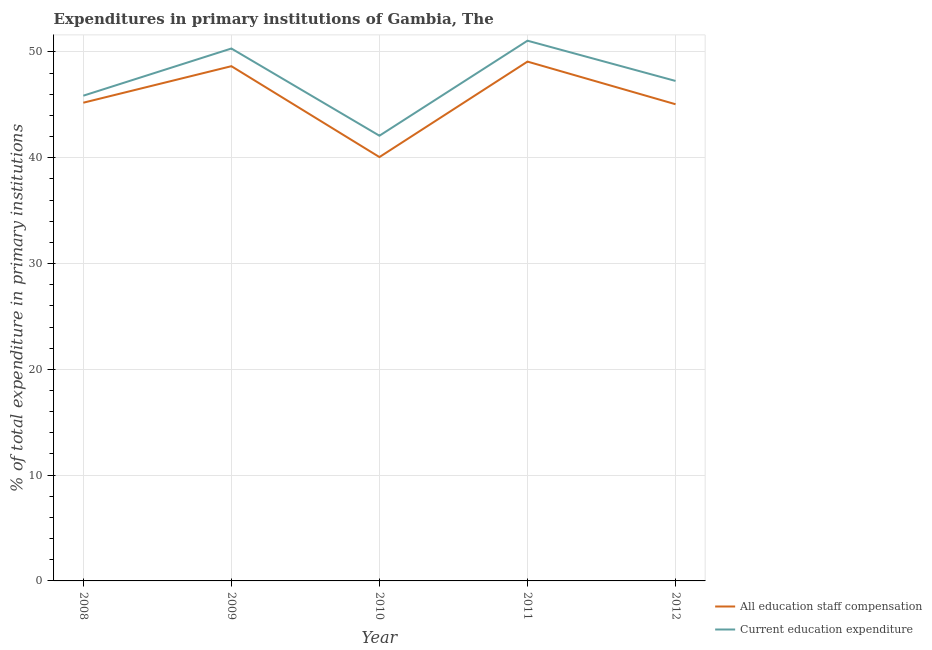Does the line corresponding to expenditure in staff compensation intersect with the line corresponding to expenditure in education?
Keep it short and to the point. No. What is the expenditure in education in 2012?
Offer a very short reply. 47.26. Across all years, what is the maximum expenditure in education?
Make the answer very short. 51.07. Across all years, what is the minimum expenditure in staff compensation?
Provide a short and direct response. 40.06. In which year was the expenditure in education maximum?
Your answer should be very brief. 2011. What is the total expenditure in staff compensation in the graph?
Your response must be concise. 228.07. What is the difference between the expenditure in staff compensation in 2008 and that in 2009?
Give a very brief answer. -3.45. What is the difference between the expenditure in education in 2010 and the expenditure in staff compensation in 2008?
Give a very brief answer. -3.12. What is the average expenditure in staff compensation per year?
Keep it short and to the point. 45.61. In the year 2010, what is the difference between the expenditure in staff compensation and expenditure in education?
Your response must be concise. -2.02. In how many years, is the expenditure in staff compensation greater than 46 %?
Your answer should be compact. 2. What is the ratio of the expenditure in education in 2008 to that in 2012?
Provide a succinct answer. 0.97. Is the expenditure in education in 2008 less than that in 2010?
Provide a succinct answer. No. What is the difference between the highest and the second highest expenditure in education?
Your answer should be very brief. 0.74. What is the difference between the highest and the lowest expenditure in education?
Offer a terse response. 8.98. In how many years, is the expenditure in education greater than the average expenditure in education taken over all years?
Ensure brevity in your answer.  2. Does the expenditure in staff compensation monotonically increase over the years?
Make the answer very short. No. Is the expenditure in staff compensation strictly less than the expenditure in education over the years?
Make the answer very short. Yes. How many years are there in the graph?
Offer a terse response. 5. What is the difference between two consecutive major ticks on the Y-axis?
Provide a short and direct response. 10. Does the graph contain any zero values?
Provide a succinct answer. No. Does the graph contain grids?
Offer a very short reply. Yes. What is the title of the graph?
Your answer should be compact. Expenditures in primary institutions of Gambia, The. Does "Mobile cellular" appear as one of the legend labels in the graph?
Offer a terse response. No. What is the label or title of the Y-axis?
Offer a terse response. % of total expenditure in primary institutions. What is the % of total expenditure in primary institutions of All education staff compensation in 2008?
Offer a terse response. 45.2. What is the % of total expenditure in primary institutions in Current education expenditure in 2008?
Provide a succinct answer. 45.87. What is the % of total expenditure in primary institutions in All education staff compensation in 2009?
Offer a very short reply. 48.66. What is the % of total expenditure in primary institutions of Current education expenditure in 2009?
Make the answer very short. 50.33. What is the % of total expenditure in primary institutions in All education staff compensation in 2010?
Keep it short and to the point. 40.06. What is the % of total expenditure in primary institutions of Current education expenditure in 2010?
Provide a short and direct response. 42.08. What is the % of total expenditure in primary institutions in All education staff compensation in 2011?
Your answer should be very brief. 49.09. What is the % of total expenditure in primary institutions in Current education expenditure in 2011?
Your answer should be very brief. 51.07. What is the % of total expenditure in primary institutions of All education staff compensation in 2012?
Provide a short and direct response. 45.06. What is the % of total expenditure in primary institutions in Current education expenditure in 2012?
Offer a terse response. 47.26. Across all years, what is the maximum % of total expenditure in primary institutions in All education staff compensation?
Provide a succinct answer. 49.09. Across all years, what is the maximum % of total expenditure in primary institutions in Current education expenditure?
Ensure brevity in your answer.  51.07. Across all years, what is the minimum % of total expenditure in primary institutions in All education staff compensation?
Provide a succinct answer. 40.06. Across all years, what is the minimum % of total expenditure in primary institutions of Current education expenditure?
Make the answer very short. 42.08. What is the total % of total expenditure in primary institutions in All education staff compensation in the graph?
Make the answer very short. 228.07. What is the total % of total expenditure in primary institutions of Current education expenditure in the graph?
Keep it short and to the point. 236.6. What is the difference between the % of total expenditure in primary institutions of All education staff compensation in 2008 and that in 2009?
Offer a terse response. -3.45. What is the difference between the % of total expenditure in primary institutions in Current education expenditure in 2008 and that in 2009?
Offer a very short reply. -4.46. What is the difference between the % of total expenditure in primary institutions of All education staff compensation in 2008 and that in 2010?
Your answer should be very brief. 5.14. What is the difference between the % of total expenditure in primary institutions of Current education expenditure in 2008 and that in 2010?
Make the answer very short. 3.78. What is the difference between the % of total expenditure in primary institutions of All education staff compensation in 2008 and that in 2011?
Keep it short and to the point. -3.89. What is the difference between the % of total expenditure in primary institutions in Current education expenditure in 2008 and that in 2011?
Make the answer very short. -5.2. What is the difference between the % of total expenditure in primary institutions of All education staff compensation in 2008 and that in 2012?
Your answer should be very brief. 0.15. What is the difference between the % of total expenditure in primary institutions of Current education expenditure in 2008 and that in 2012?
Your answer should be very brief. -1.39. What is the difference between the % of total expenditure in primary institutions in All education staff compensation in 2009 and that in 2010?
Ensure brevity in your answer.  8.59. What is the difference between the % of total expenditure in primary institutions of Current education expenditure in 2009 and that in 2010?
Your response must be concise. 8.24. What is the difference between the % of total expenditure in primary institutions in All education staff compensation in 2009 and that in 2011?
Give a very brief answer. -0.43. What is the difference between the % of total expenditure in primary institutions of Current education expenditure in 2009 and that in 2011?
Offer a terse response. -0.74. What is the difference between the % of total expenditure in primary institutions of All education staff compensation in 2009 and that in 2012?
Your answer should be very brief. 3.6. What is the difference between the % of total expenditure in primary institutions in Current education expenditure in 2009 and that in 2012?
Give a very brief answer. 3.07. What is the difference between the % of total expenditure in primary institutions of All education staff compensation in 2010 and that in 2011?
Your answer should be compact. -9.03. What is the difference between the % of total expenditure in primary institutions of Current education expenditure in 2010 and that in 2011?
Give a very brief answer. -8.98. What is the difference between the % of total expenditure in primary institutions of All education staff compensation in 2010 and that in 2012?
Keep it short and to the point. -4.99. What is the difference between the % of total expenditure in primary institutions in Current education expenditure in 2010 and that in 2012?
Your response must be concise. -5.18. What is the difference between the % of total expenditure in primary institutions in All education staff compensation in 2011 and that in 2012?
Make the answer very short. 4.03. What is the difference between the % of total expenditure in primary institutions in Current education expenditure in 2011 and that in 2012?
Your answer should be compact. 3.8. What is the difference between the % of total expenditure in primary institutions of All education staff compensation in 2008 and the % of total expenditure in primary institutions of Current education expenditure in 2009?
Your response must be concise. -5.12. What is the difference between the % of total expenditure in primary institutions of All education staff compensation in 2008 and the % of total expenditure in primary institutions of Current education expenditure in 2010?
Offer a very short reply. 3.12. What is the difference between the % of total expenditure in primary institutions in All education staff compensation in 2008 and the % of total expenditure in primary institutions in Current education expenditure in 2011?
Offer a very short reply. -5.86. What is the difference between the % of total expenditure in primary institutions in All education staff compensation in 2008 and the % of total expenditure in primary institutions in Current education expenditure in 2012?
Your answer should be compact. -2.06. What is the difference between the % of total expenditure in primary institutions of All education staff compensation in 2009 and the % of total expenditure in primary institutions of Current education expenditure in 2010?
Your answer should be very brief. 6.57. What is the difference between the % of total expenditure in primary institutions of All education staff compensation in 2009 and the % of total expenditure in primary institutions of Current education expenditure in 2011?
Provide a succinct answer. -2.41. What is the difference between the % of total expenditure in primary institutions in All education staff compensation in 2009 and the % of total expenditure in primary institutions in Current education expenditure in 2012?
Make the answer very short. 1.4. What is the difference between the % of total expenditure in primary institutions in All education staff compensation in 2010 and the % of total expenditure in primary institutions in Current education expenditure in 2011?
Provide a succinct answer. -11. What is the difference between the % of total expenditure in primary institutions in All education staff compensation in 2010 and the % of total expenditure in primary institutions in Current education expenditure in 2012?
Offer a very short reply. -7.2. What is the difference between the % of total expenditure in primary institutions of All education staff compensation in 2011 and the % of total expenditure in primary institutions of Current education expenditure in 2012?
Make the answer very short. 1.83. What is the average % of total expenditure in primary institutions of All education staff compensation per year?
Provide a short and direct response. 45.61. What is the average % of total expenditure in primary institutions of Current education expenditure per year?
Keep it short and to the point. 47.32. In the year 2008, what is the difference between the % of total expenditure in primary institutions in All education staff compensation and % of total expenditure in primary institutions in Current education expenditure?
Offer a very short reply. -0.66. In the year 2009, what is the difference between the % of total expenditure in primary institutions of All education staff compensation and % of total expenditure in primary institutions of Current education expenditure?
Make the answer very short. -1.67. In the year 2010, what is the difference between the % of total expenditure in primary institutions in All education staff compensation and % of total expenditure in primary institutions in Current education expenditure?
Give a very brief answer. -2.02. In the year 2011, what is the difference between the % of total expenditure in primary institutions of All education staff compensation and % of total expenditure in primary institutions of Current education expenditure?
Your answer should be compact. -1.98. In the year 2012, what is the difference between the % of total expenditure in primary institutions in All education staff compensation and % of total expenditure in primary institutions in Current education expenditure?
Provide a short and direct response. -2.2. What is the ratio of the % of total expenditure in primary institutions in All education staff compensation in 2008 to that in 2009?
Keep it short and to the point. 0.93. What is the ratio of the % of total expenditure in primary institutions in Current education expenditure in 2008 to that in 2009?
Provide a succinct answer. 0.91. What is the ratio of the % of total expenditure in primary institutions in All education staff compensation in 2008 to that in 2010?
Keep it short and to the point. 1.13. What is the ratio of the % of total expenditure in primary institutions in Current education expenditure in 2008 to that in 2010?
Provide a succinct answer. 1.09. What is the ratio of the % of total expenditure in primary institutions of All education staff compensation in 2008 to that in 2011?
Your answer should be very brief. 0.92. What is the ratio of the % of total expenditure in primary institutions in Current education expenditure in 2008 to that in 2011?
Give a very brief answer. 0.9. What is the ratio of the % of total expenditure in primary institutions in Current education expenditure in 2008 to that in 2012?
Offer a very short reply. 0.97. What is the ratio of the % of total expenditure in primary institutions of All education staff compensation in 2009 to that in 2010?
Ensure brevity in your answer.  1.21. What is the ratio of the % of total expenditure in primary institutions of Current education expenditure in 2009 to that in 2010?
Your response must be concise. 1.2. What is the ratio of the % of total expenditure in primary institutions of Current education expenditure in 2009 to that in 2011?
Keep it short and to the point. 0.99. What is the ratio of the % of total expenditure in primary institutions of All education staff compensation in 2009 to that in 2012?
Your answer should be compact. 1.08. What is the ratio of the % of total expenditure in primary institutions of Current education expenditure in 2009 to that in 2012?
Ensure brevity in your answer.  1.06. What is the ratio of the % of total expenditure in primary institutions in All education staff compensation in 2010 to that in 2011?
Provide a short and direct response. 0.82. What is the ratio of the % of total expenditure in primary institutions of Current education expenditure in 2010 to that in 2011?
Provide a short and direct response. 0.82. What is the ratio of the % of total expenditure in primary institutions in All education staff compensation in 2010 to that in 2012?
Offer a very short reply. 0.89. What is the ratio of the % of total expenditure in primary institutions of Current education expenditure in 2010 to that in 2012?
Offer a terse response. 0.89. What is the ratio of the % of total expenditure in primary institutions in All education staff compensation in 2011 to that in 2012?
Offer a terse response. 1.09. What is the ratio of the % of total expenditure in primary institutions of Current education expenditure in 2011 to that in 2012?
Provide a succinct answer. 1.08. What is the difference between the highest and the second highest % of total expenditure in primary institutions of All education staff compensation?
Your answer should be very brief. 0.43. What is the difference between the highest and the second highest % of total expenditure in primary institutions in Current education expenditure?
Provide a short and direct response. 0.74. What is the difference between the highest and the lowest % of total expenditure in primary institutions in All education staff compensation?
Your answer should be very brief. 9.03. What is the difference between the highest and the lowest % of total expenditure in primary institutions of Current education expenditure?
Give a very brief answer. 8.98. 